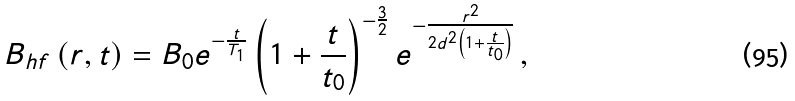<formula> <loc_0><loc_0><loc_500><loc_500>B _ { h f } \left ( r , t \right ) = B _ { 0 } e ^ { - \frac { t } { T _ { 1 } } } \left ( 1 + \frac { t } { t _ { 0 } } \right ) ^ { - \frac { 3 } { 2 } } e ^ { - \frac { r ^ { 2 } } { 2 d ^ { 2 } \left ( 1 + \frac { t } { t _ { 0 } } \right ) } } \, ,</formula> 